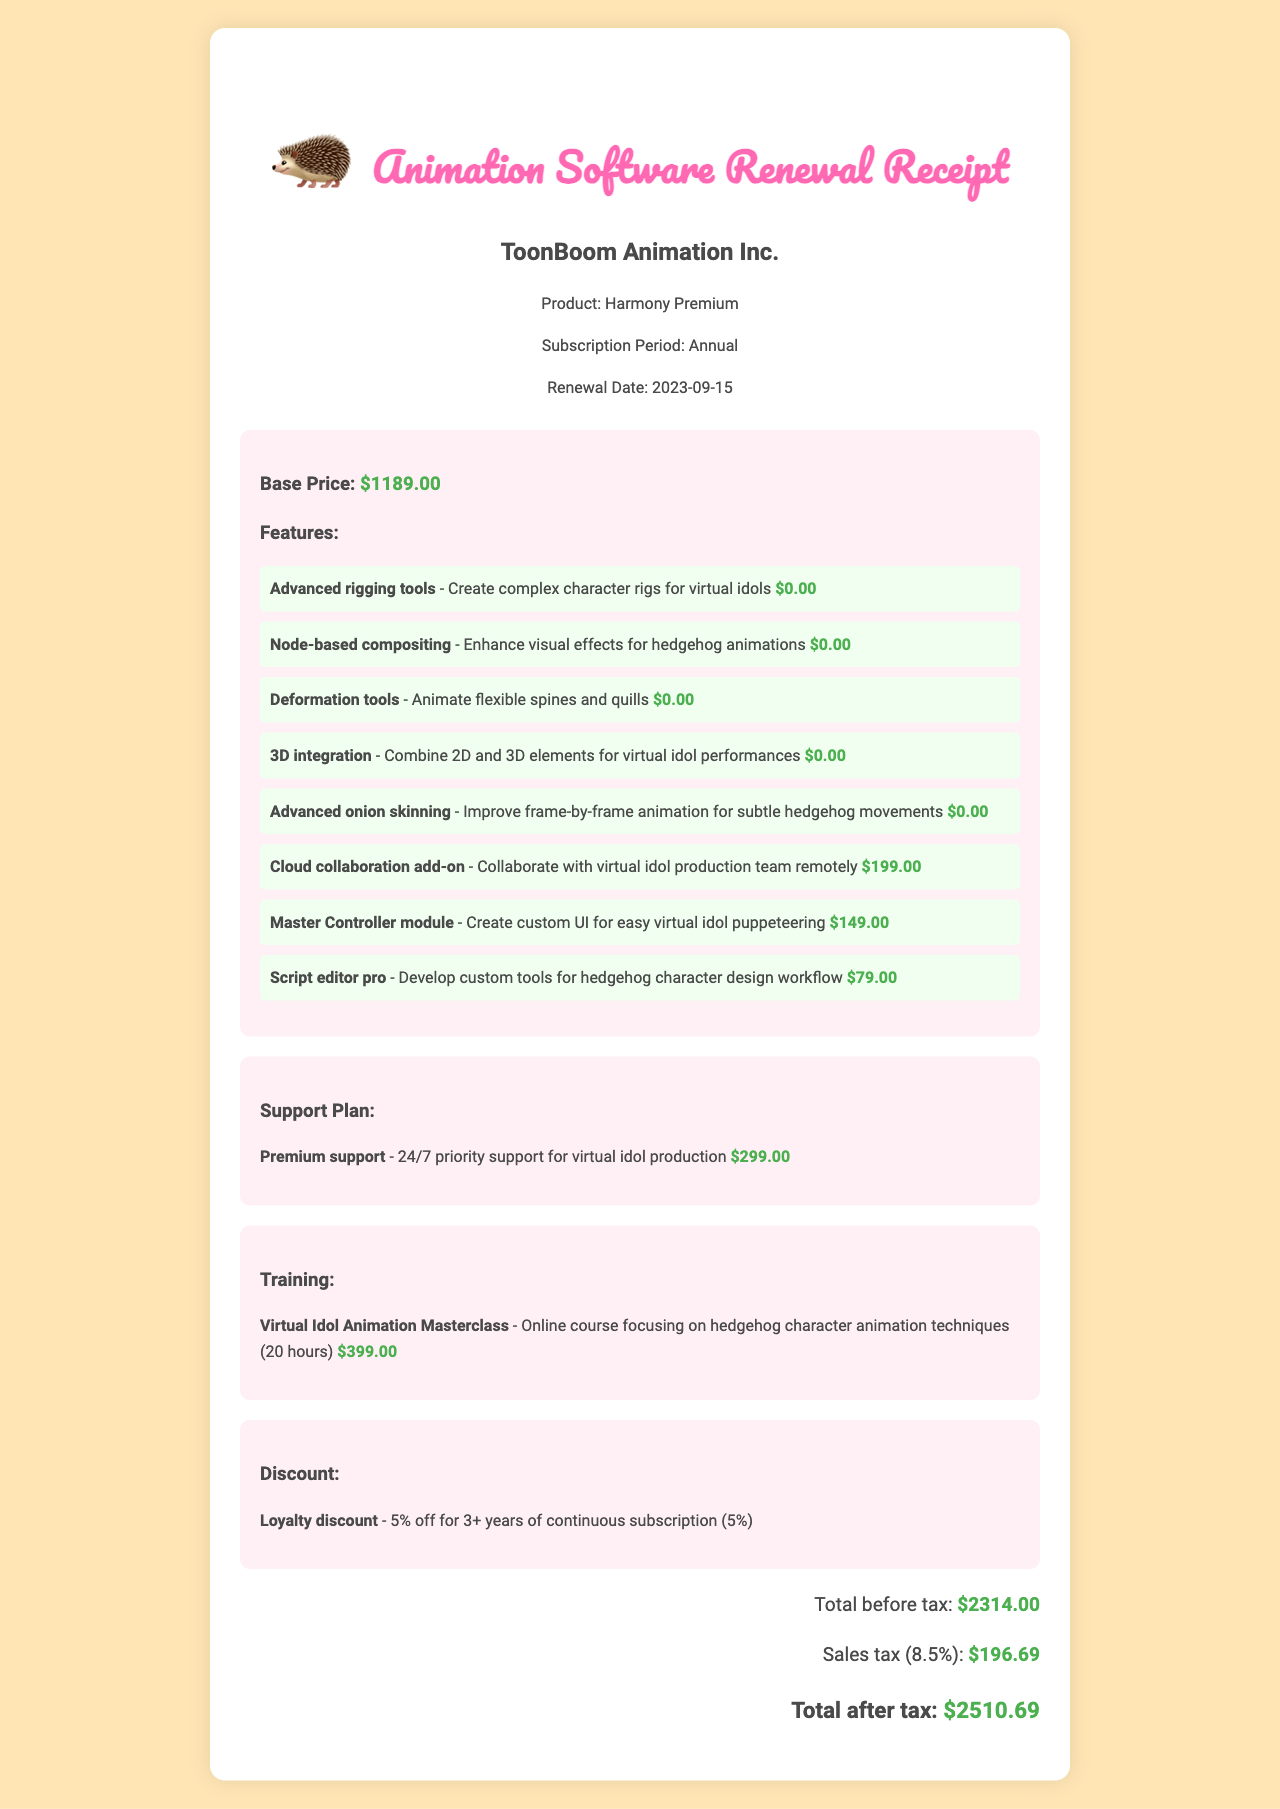What is the company name? The company name is stated at the top of the receipt, identifying who is issuing the document.
Answer: ToonBoom Animation Inc What is the total price after tax? The total price after tax is provided at the end of the receipt, summarizing the total expense for the subscription.
Answer: $2510.69 What is the subscription period? The subscription period indicates how long the service is active before renewal, as mentioned in the document.
Answer: Annual What feature costs $199? The features listed have associated costs, and one of them is specified as costing $199.
Answer: Cloud collaboration add-on How much is the training course? The price for the training course is explicitly mentioned, allowing for easy retrieval of the cost.
Answer: $399.00 What percentage is the loyalty discount? The loyalty discount percentage is noted in the document, helping to understand potential savings.
Answer: 5% What is included in the support plan? The support plan section details the nature of the support included with the subscription and its cost.
Answer: 24/7 priority support What is the name of the animation software? The name of the specific product being renewed is highlighted, indicating the focus of the receipt.
Answer: Harmony Premium What is the renewal date? The renewal date shows when the subscription becomes active again, an important date for billing records.
Answer: 2023-09-15 